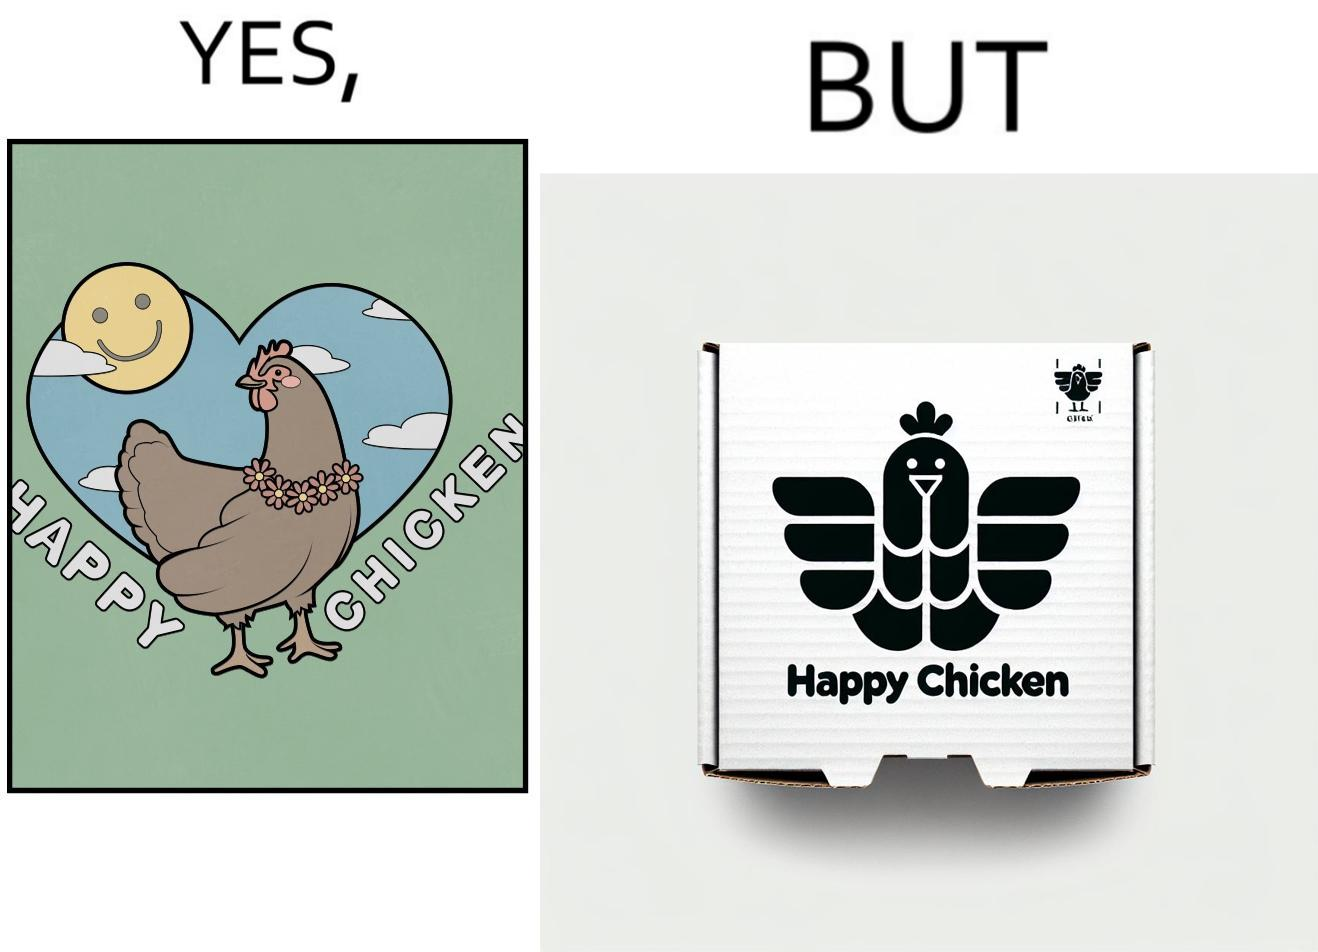Is this image satirical or non-satirical? Yes, this image is satirical. 